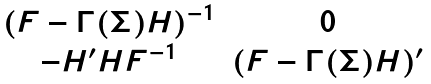<formula> <loc_0><loc_0><loc_500><loc_500>\begin{matrix} ( F - \Gamma ( \Sigma ) H ) ^ { - 1 } & 0 \\ - H ^ { \prime } H F ^ { - 1 } & ( F - \Gamma ( \Sigma ) H ) ^ { \prime } \end{matrix}</formula> 